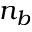Convert formula to latex. <formula><loc_0><loc_0><loc_500><loc_500>n _ { b }</formula> 